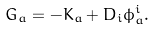Convert formula to latex. <formula><loc_0><loc_0><loc_500><loc_500>G _ { a } = - K _ { a } + D _ { i } \phi ^ { i } _ { a } .</formula> 